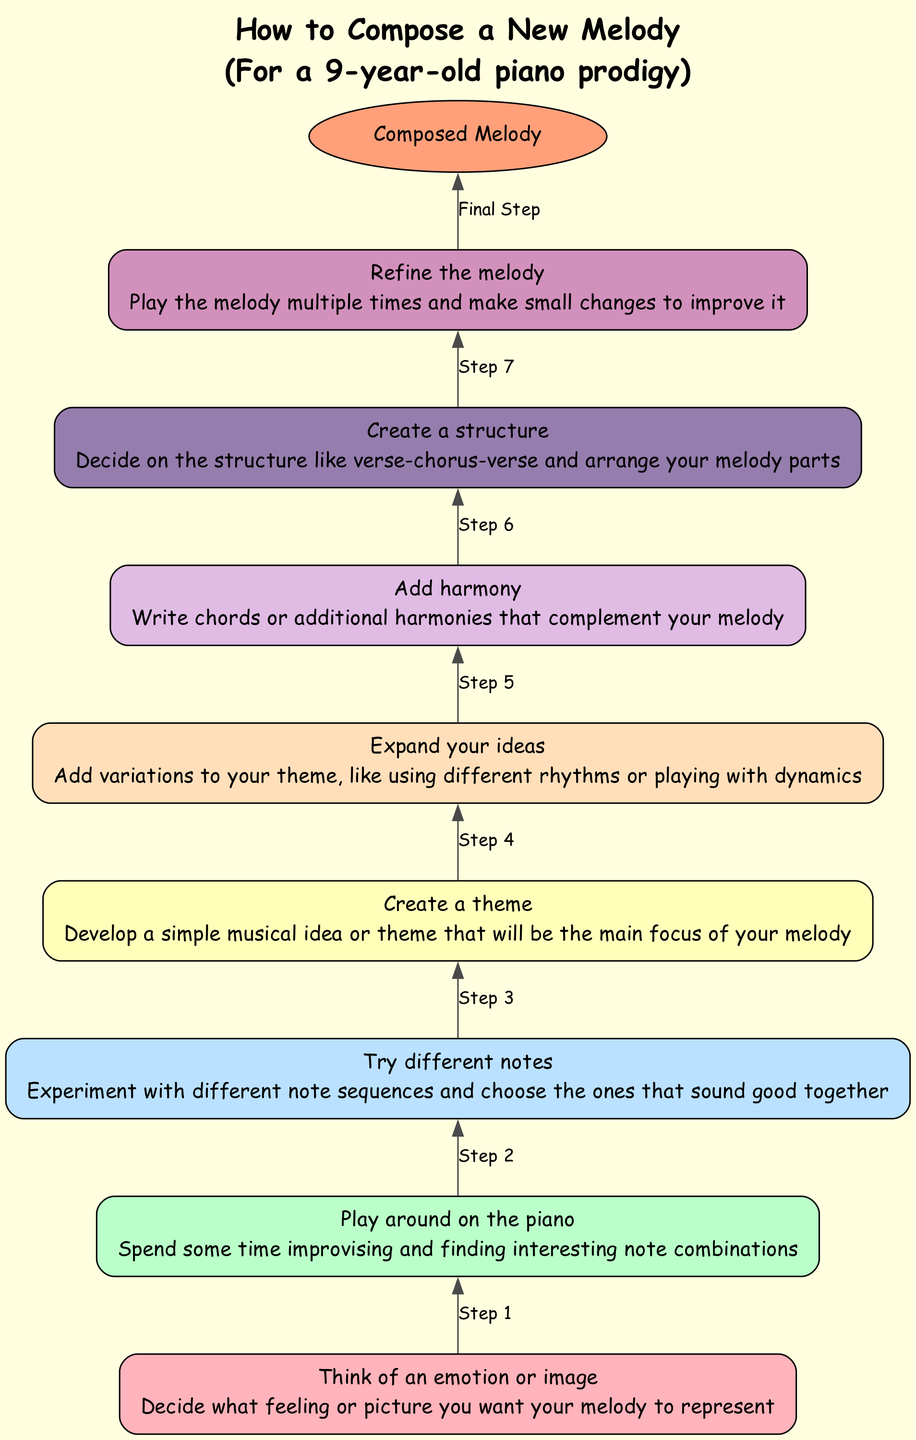What is the last step before composing the melody? The last step before composing the melody is "Refine the melody", which is represented just above the "Composed Melody" end node.
Answer: Refine the melody How many nodes are in total in the diagram? Counting all the steps plus the end node, there are 8 nodes in total (including the nodes from "Start" to "Improve" and the "Composed Melody" end).
Answer: 8 Which step involves adding harmony? The step that involves adding harmony is labeled "Add harmony". It comes after "Expand your ideas" in the flow.
Answer: Add harmony What is the focus of the entire composition process according to the diagram? The focus of the composition process is to develop a "simple musical idea or theme", which is the main concept to be elaborated upon in the melody.
Answer: Simple musical idea or theme Which step comes right after "Play around on the piano"? The step that comes right after "Play around on the piano" is "Try different notes", indicating a flow from improvisation to experimentation with notes.
Answer: Try different notes Which emotion or image should you decide on first? You should decide on "an emotion or image" first, as shown in the "Think of an emotion or image" step at the bottom of the flowchart.
Answer: An emotion or image How do you enhance your melody after creating it? After creating the melody, you'll "Refine the melody", which involves playing it multiple times and making small changes to enhance it.
Answer: Refine the melody What sequence of steps leads to composing the melody? The sequence leading to composing the melody starts with "Think of an emotion or image", continues with "Play around on the piano", and ends with "Refine the melody" before achieving the final goal.
Answer: Think of an emotion or image, Play around on the piano, Refine the melody 